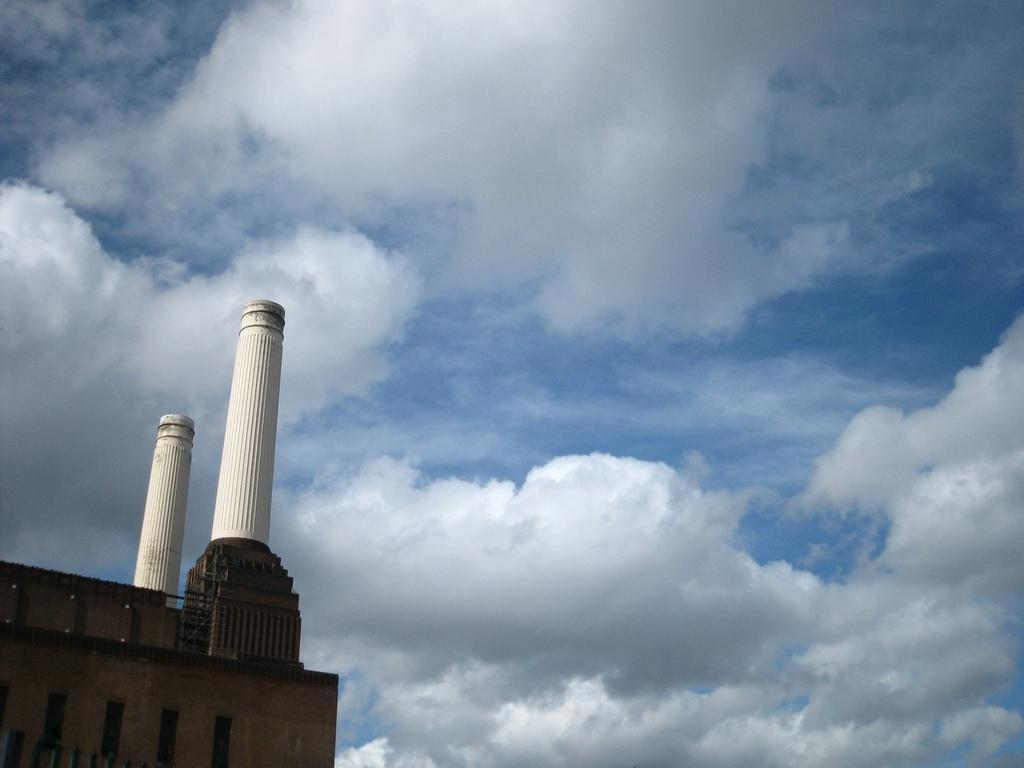What type of structure is present in the image? There is a building in the image. What is the color of the building? The building is brown in color. How many towers are on the building? There are two towers on the building. What is the color of the towers? The towers are white in color. What can be seen in the background of the image? The sky is visible in the background of the image. Can you describe the flesh of the friend who is part of the government in the image? There is no friend or government official present in the image, and therefore no flesh to describe. 